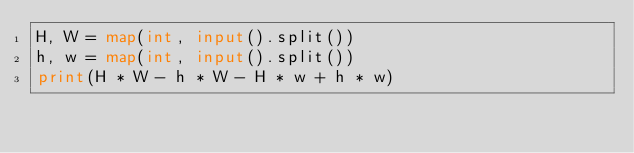Convert code to text. <code><loc_0><loc_0><loc_500><loc_500><_Python_>H, W = map(int, input().split())
h, w = map(int, input().split())
print(H * W - h * W - H * w + h * w)
</code> 